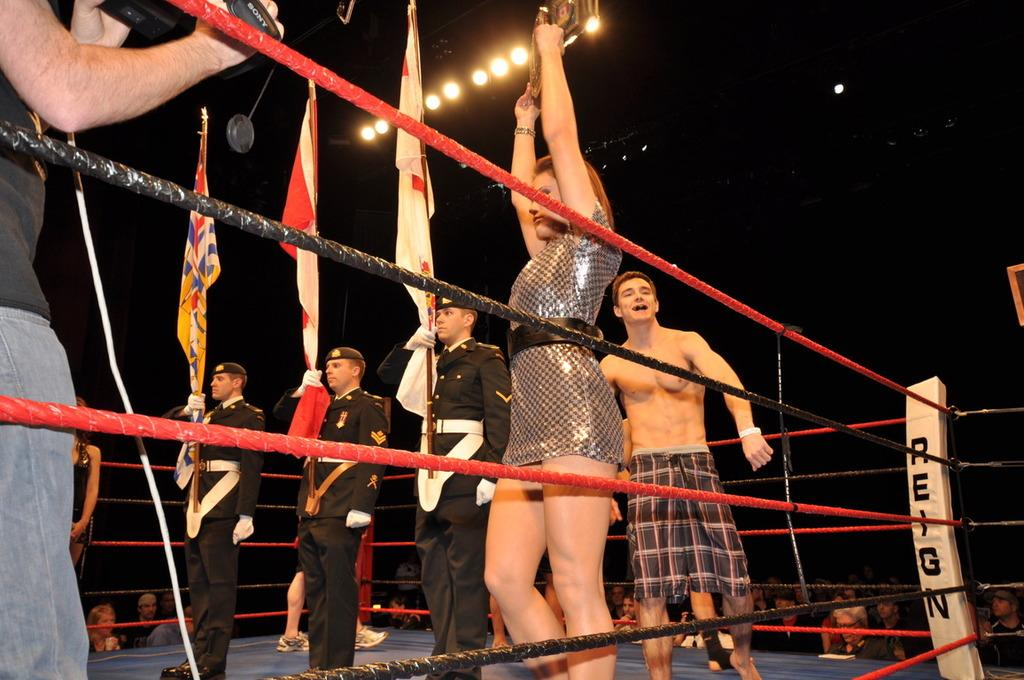<image>
Give a short and clear explanation of the subsequent image. Soldiers holding flags in side a boxing ring that says "Reign". 